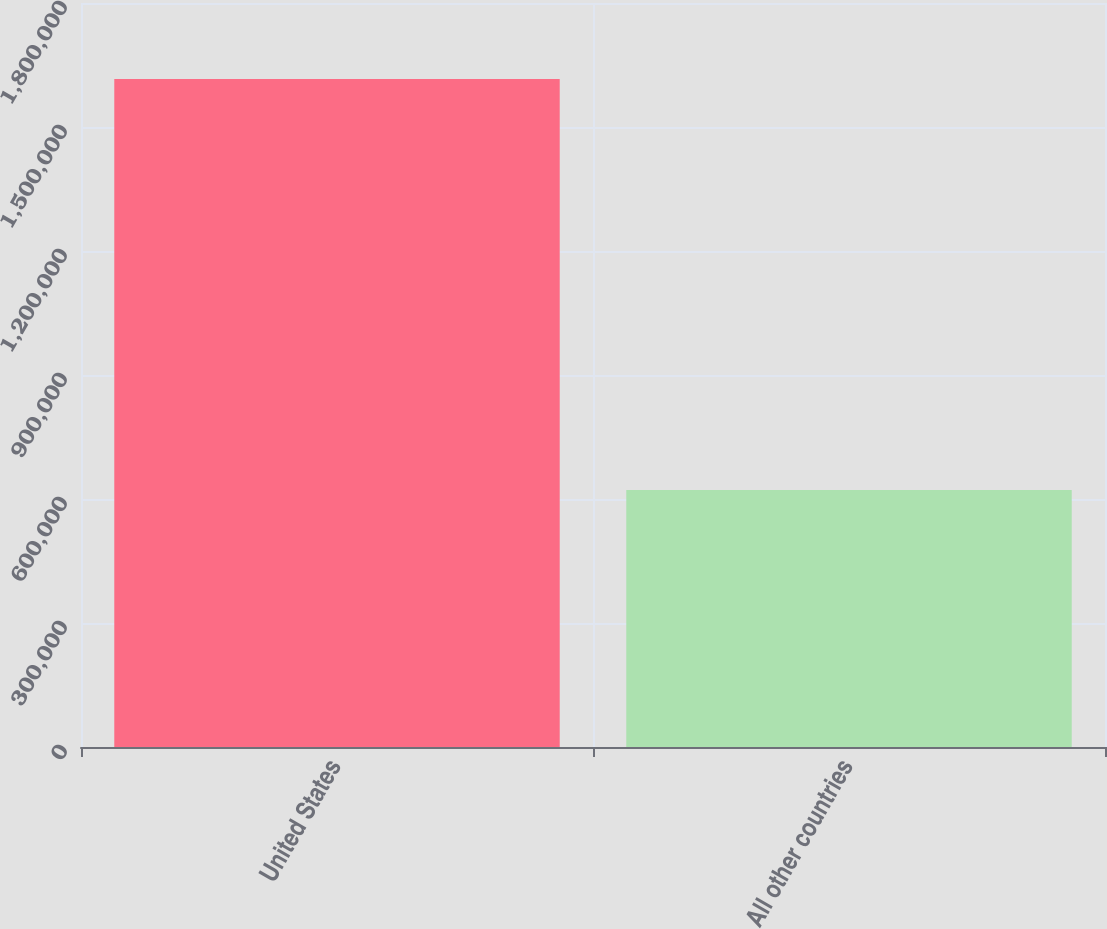<chart> <loc_0><loc_0><loc_500><loc_500><bar_chart><fcel>United States<fcel>All other countries<nl><fcel>1.61593e+06<fcel>621657<nl></chart> 